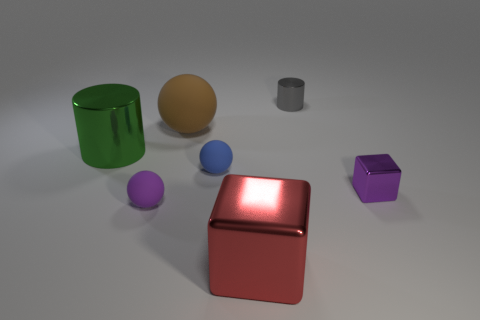Add 2 large green matte cylinders. How many objects exist? 9 Subtract all tiny balls. How many balls are left? 1 Subtract all green cylinders. How many cylinders are left? 1 Subtract 2 spheres. How many spheres are left? 1 Add 4 yellow blocks. How many yellow blocks exist? 4 Subtract 1 green cylinders. How many objects are left? 6 Subtract all cubes. How many objects are left? 5 Subtract all green cylinders. Subtract all green balls. How many cylinders are left? 1 Subtract all brown balls. How many yellow blocks are left? 0 Subtract all blue things. Subtract all green cylinders. How many objects are left? 5 